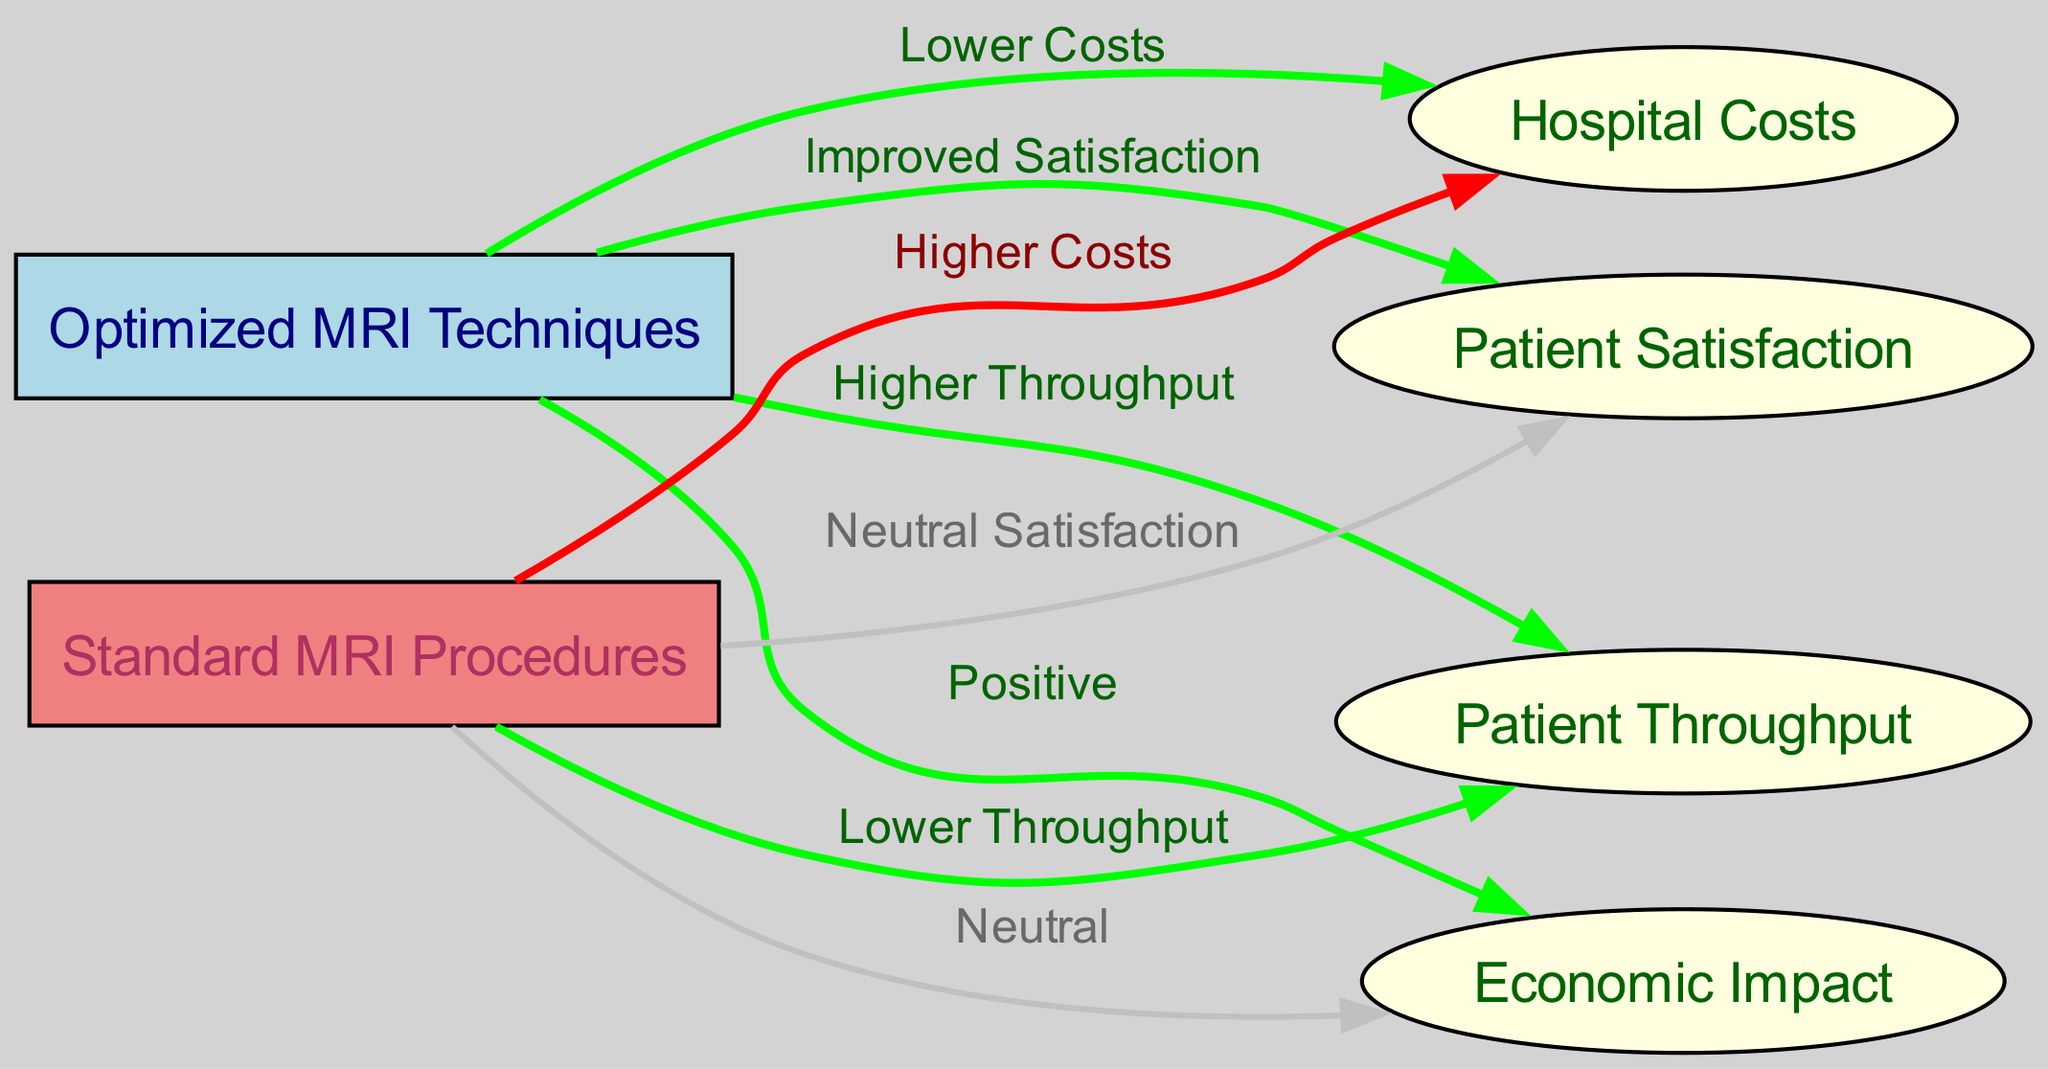What are the two MRI technique types shown in the diagram? The diagram displays nodes for "Optimized MRI Techniques" and "Standard MRI Procedures", representing the two types being compared in terms of their impact on patient throughput efficiency.
Answer: Optimized MRI Techniques, Standard MRI Procedures What is the effect of optimized MRI techniques on hospital costs? The edge connecting "Optimized MRI Techniques" to "Hospital Costs" is labeled "Lower Costs", indicating that implementing optimized methods reduces the hospital's financial burden.
Answer: Lower Costs How does patient throughput differ between the two MRI techniques? The diagram shows that "Optimized MRI Techniques" lead to "Higher Throughput" while "Standard MRI Procedures" result in "Lower Throughput". This comparison highlights the efficiency of the optimized techniques.
Answer: Higher Throughput, Lower Throughput Which procedure contributes to a positive economic impact? The connection from "Optimized MRI Techniques" to "Economic Impact" is labeled as "Positive", while the standard procedure has a neutral effect, therefore the optimized techniques are the ones that enhance economic outcomes.
Answer: Positive How many edges connect to the node representing patient satisfaction? The node "Patient Satisfaction" has two incoming edges: one from "Optimized MRI Techniques" labeled "Improved Satisfaction" and one from "Standard MRI Procedures" labeled "Neutral Satisfaction". Therefore, there are two connections.
Answer: 2 What is the label of the relationship between standard MRI procedures and hospital costs? The edge from "Standard MRI Procedures" to "Hospital Costs" is labeled "Higher Costs", indicating the financial implications of using standard procedures compared to optimized ones.
Answer: Higher Costs Does the diagram indicate improved patient satisfaction with optimized methods? The edge from "Optimized MRI Techniques" to "Patient Satisfaction" is labeled "Improved Satisfaction", confirming that these techniques enhance patient experiences compared to the standard procedures.
Answer: Improved Satisfaction What type of relationship connects optimized MRI techniques to patient throughput? The relationship is indicated by an edge labeled "Higher Throughput", suggesting that optimized techniques allow for more patients to be processed in the same timeframe compared to standard methods.
Answer: Higher Throughput What color represents nodes for standard MRI procedures in the diagram? The nodes representing standard MRI procedures are filled with light coral color, distinguishing them visually from the optimized techniques, which are in light blue.
Answer: Light coral 